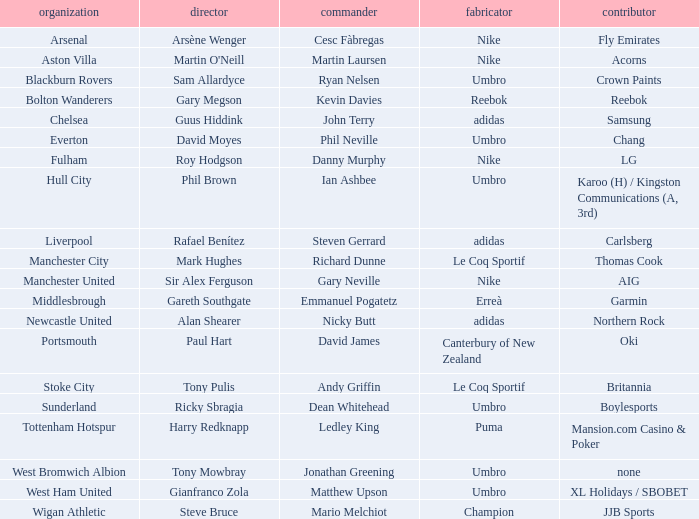Who is Dean Whitehead's manager? Ricky Sbragia. 